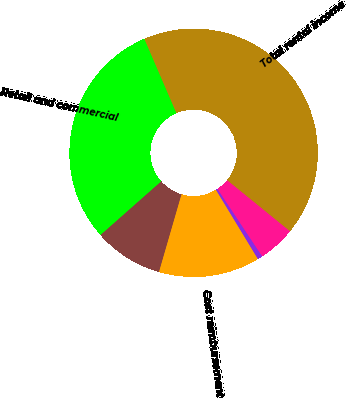Convert chart to OTSL. <chart><loc_0><loc_0><loc_500><loc_500><pie_chart><fcel>Retail and commercial<fcel>Residential<fcel>Cost reimbursement<fcel>Percentage rent<fcel>Other<fcel>Total rental income<nl><fcel>30.04%<fcel>8.99%<fcel>13.16%<fcel>0.65%<fcel>4.82%<fcel>42.35%<nl></chart> 